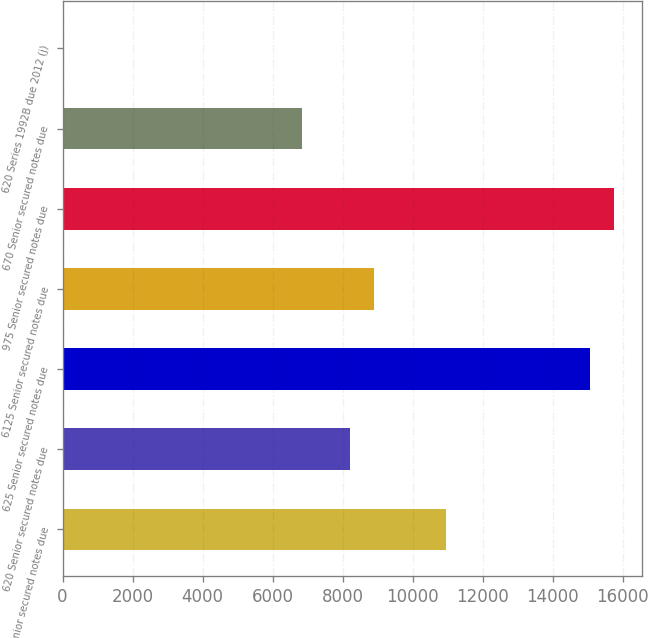<chart> <loc_0><loc_0><loc_500><loc_500><bar_chart><fcel>8875 Senior secured notes due<fcel>620 Senior secured notes due<fcel>625 Senior secured notes due<fcel>6125 Senior secured notes due<fcel>975 Senior secured notes due<fcel>670 Senior secured notes due<fcel>620 Series 1992B due 2012 (j)<nl><fcel>10964.2<fcel>8223.4<fcel>15075.4<fcel>8908.6<fcel>15760.6<fcel>6853<fcel>1<nl></chart> 